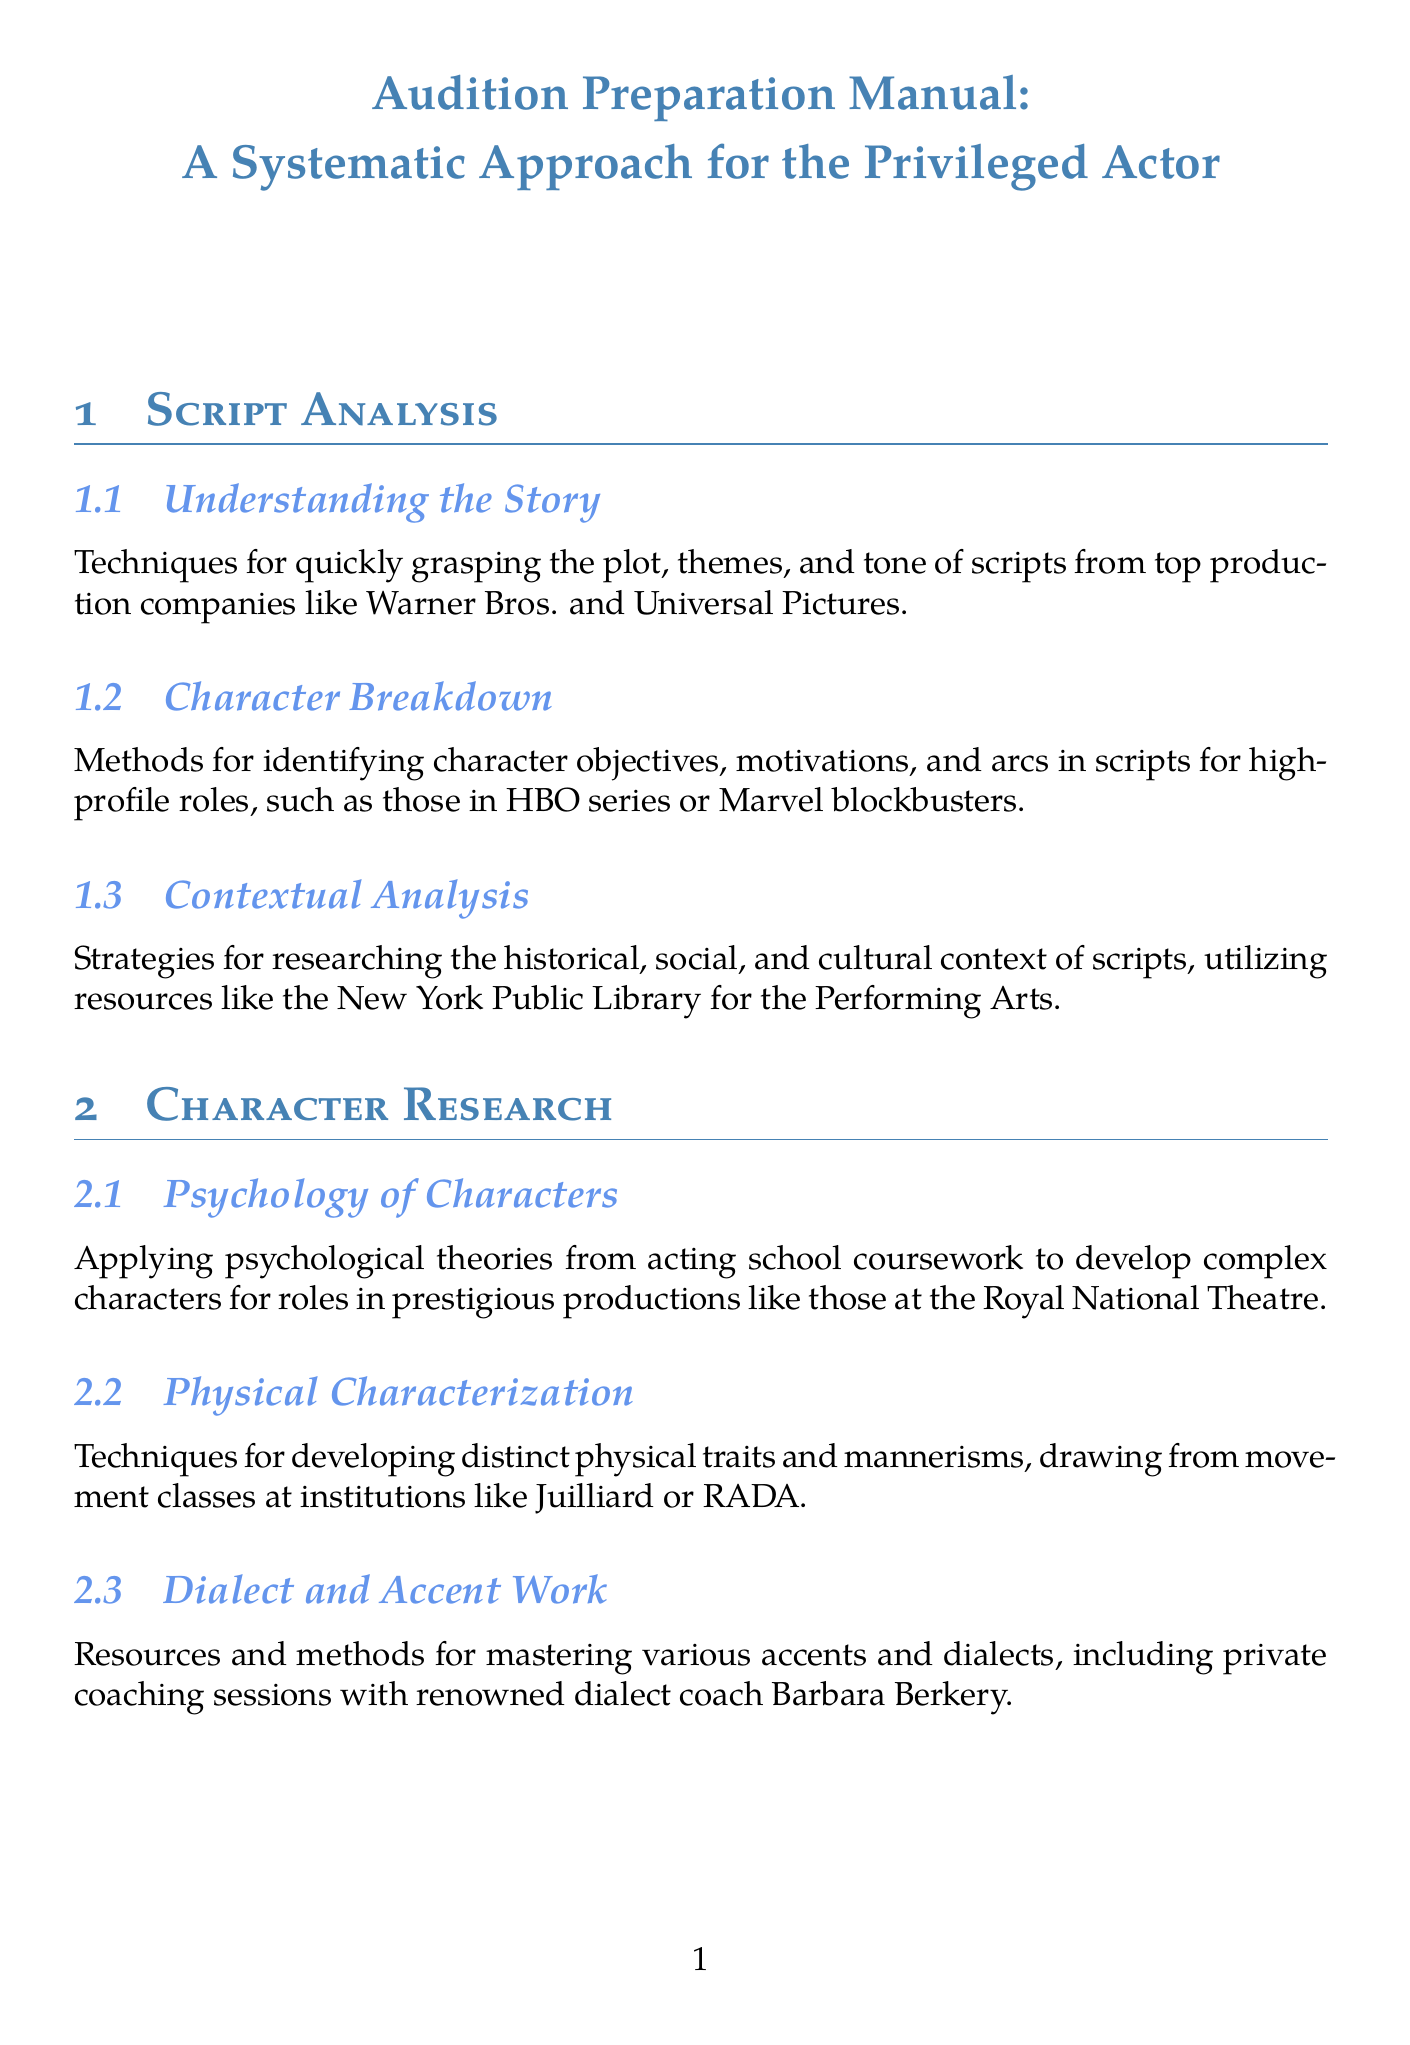What is the title of the manual? The title of the manual is presented at the beginning of the document and is "Audition Preparation Manual: A Systematic Approach for the Privileged Actor."
Answer: Audition Preparation Manual: A Systematic Approach for the Privileged Actor Which section covers methods for mastering various accents? The section that deals with accents and dialects is titled "Dialect and Accent Work," found under "Character Research."
Answer: Dialect and Accent Work What drama school is mentioned for advanced memorization techniques? The document lists the Yale School of Drama as a source for advanced memorization methods.
Answer: Yale School of Drama What are the two techniques for achieving emotional authenticity? The document mentions the Stanislavski system and Meisner technique in the context of emotional preparation.
Answer: Stanislavski system and Meisner technique Which major talent agencies are referenced in the networking section? The manual references CAA and WME as major talent agencies in the "Industry Connections" subsection.
Answer: CAA and WME What is suggested for creating professional-quality self-tapes? The guidelines for creating professional-quality self-tapes recommend using high-end equipment.
Answer: High-end equipment What should an actor focus on for in-person auditions? The document advises on appropriate attire and etiquette as crucial focuses for in-person auditions.
Answer: Appropriate attire and etiquette Which production types are specifically mentioned for high-profile character breakdowns? The document mentions HBO series and Marvel blockbusters concerning high-profile character breakdowns.
Answer: HBO series and Marvel blockbusters How can actors stay informed about industry trends? The manual suggests subscriptions to Variety and The Hollywood Reporter for staying informed about industry trends.
Answer: Subscriptions to Variety and The Hollywood Reporter 